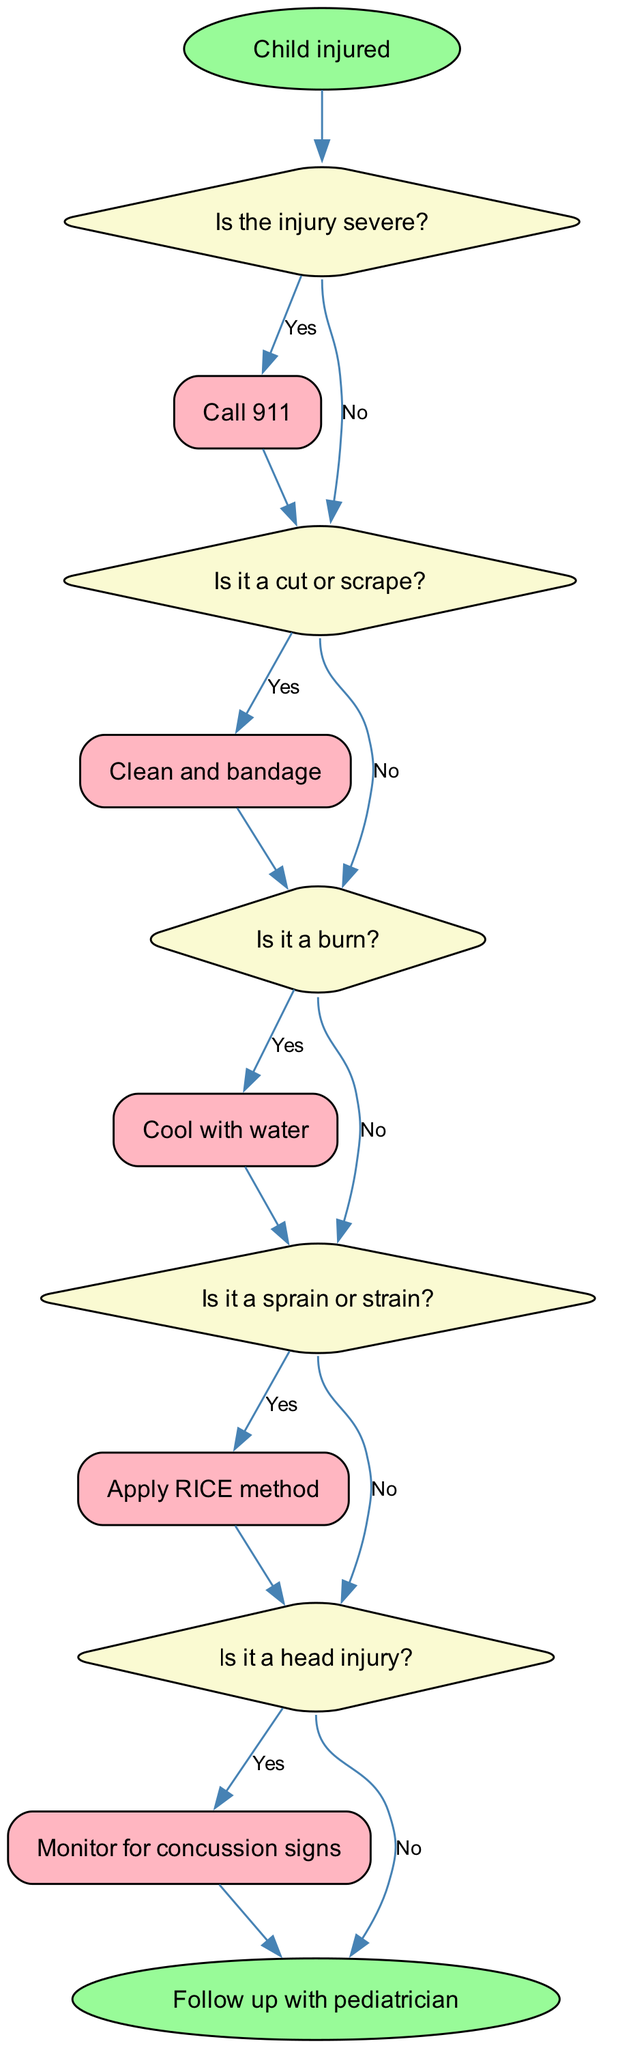Is the starting node labeled? The starting node in the diagram is "Child injured." This is confirmed by looking at the first node, which clearly states this phrase.
Answer: Yes How many decision nodes are in the diagram? The diagram includes five decision nodes, each representing a question regarding the type of injury. These nodes can be counted visually in the flowchart layout.
Answer: Five What action follows a "Yes" answer to the question about a head injury? According to the diagram, if the answer to the head injury question is "Yes," the action taken is to "Monitor for concussion signs." This is stated explicitly in the corresponding edge leading from this decision node.
Answer: Monitor for concussion signs What does the flowchart suggest if the injury is not severe? If the injury is assessed as not severe, the next step is to "Assess type of injury," which is the direct action taken following this decision node. This outcome is also illustrated in the flows from the first decision node.
Answer: Assess type of injury If the injury is a sprain, what is the recommended treatment? The flowchart states that for a sprain or strain, you should "Apply RICE method," as indicated in the relevant decision and action nodes linked to this condition.
Answer: Apply RICE method What is the terminal action at the end of the flowchart? The terminal action at the end of the flowchart is "Follow up with pediatrician." This action is depicted at the end node, illustrating the final recommendation after all other assessments have been made.
Answer: Follow up with pediatrician What would you do if it's a burn injury? If it's determined to be a burn, the diagram advises to "Cool with water," as indicated by the "Yes" edge flowing from the burn decision node to the associated action node.
Answer: Cool with water What actions lead to the end of the flowchart? There are three actions that lead to the end of the flowchart; they are "Call 911," "Monitor for concussion signs," and "Seek medical advice." Upon completion of these actions, the flowchart concludes by transitioning to the 'end' node.
Answer: Call 911, Monitor for concussion signs, Seek medical advice 